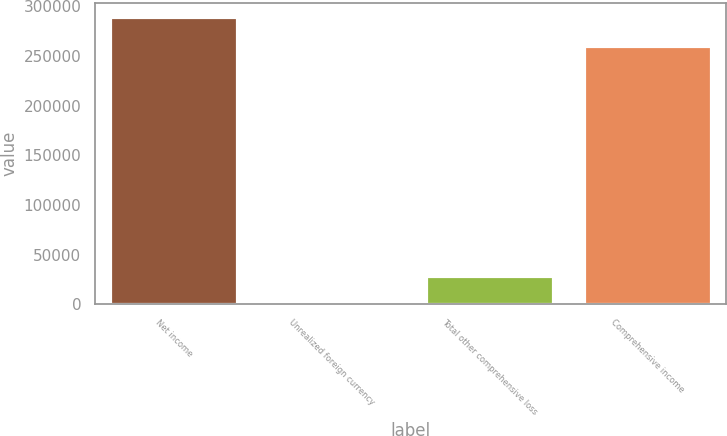Convert chart to OTSL. <chart><loc_0><loc_0><loc_500><loc_500><bar_chart><fcel>Net income<fcel>Unrealized foreign currency<fcel>Total other comprehensive loss<fcel>Comprehensive income<nl><fcel>288532<fcel>183<fcel>28440.5<fcel>260274<nl></chart> 